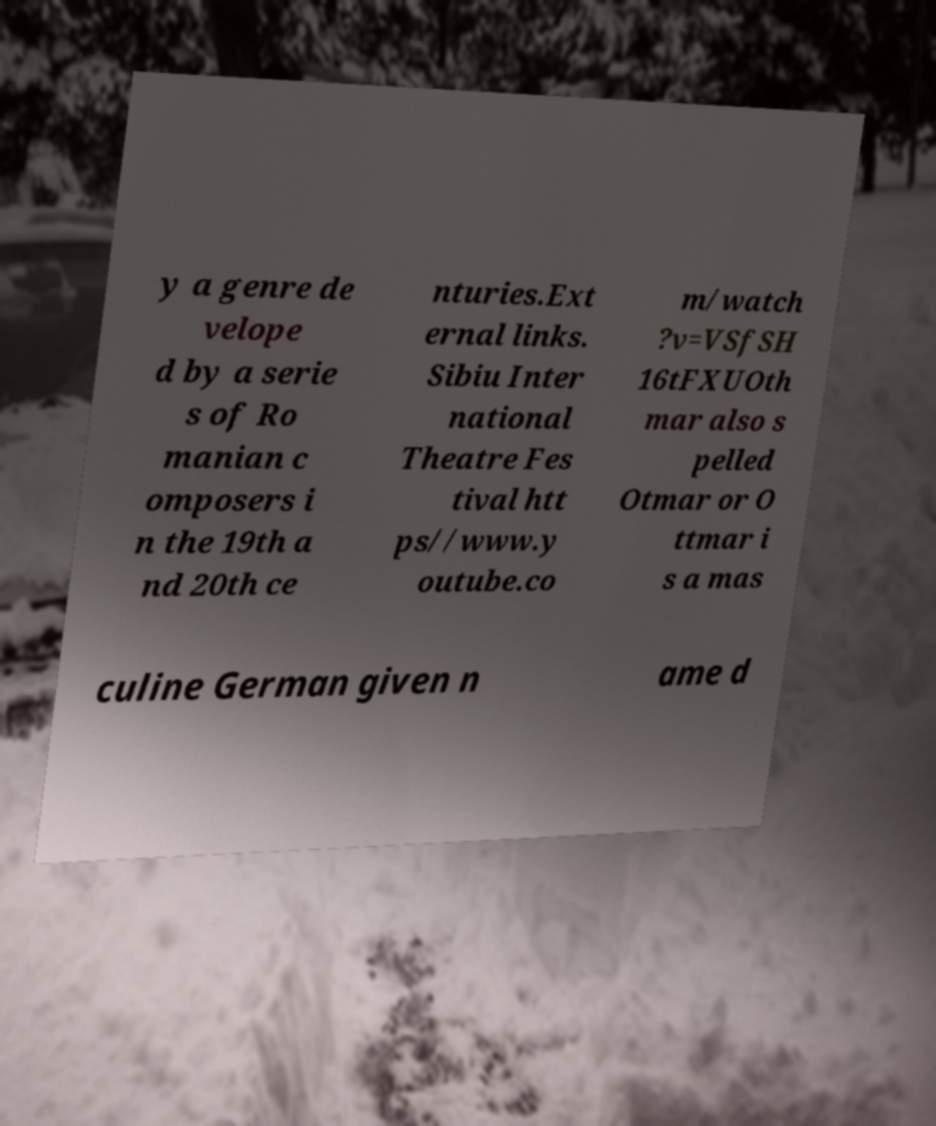What messages or text are displayed in this image? I need them in a readable, typed format. y a genre de velope d by a serie s of Ro manian c omposers i n the 19th a nd 20th ce nturies.Ext ernal links. Sibiu Inter national Theatre Fes tival htt ps//www.y outube.co m/watch ?v=VSfSH 16tFXUOth mar also s pelled Otmar or O ttmar i s a mas culine German given n ame d 